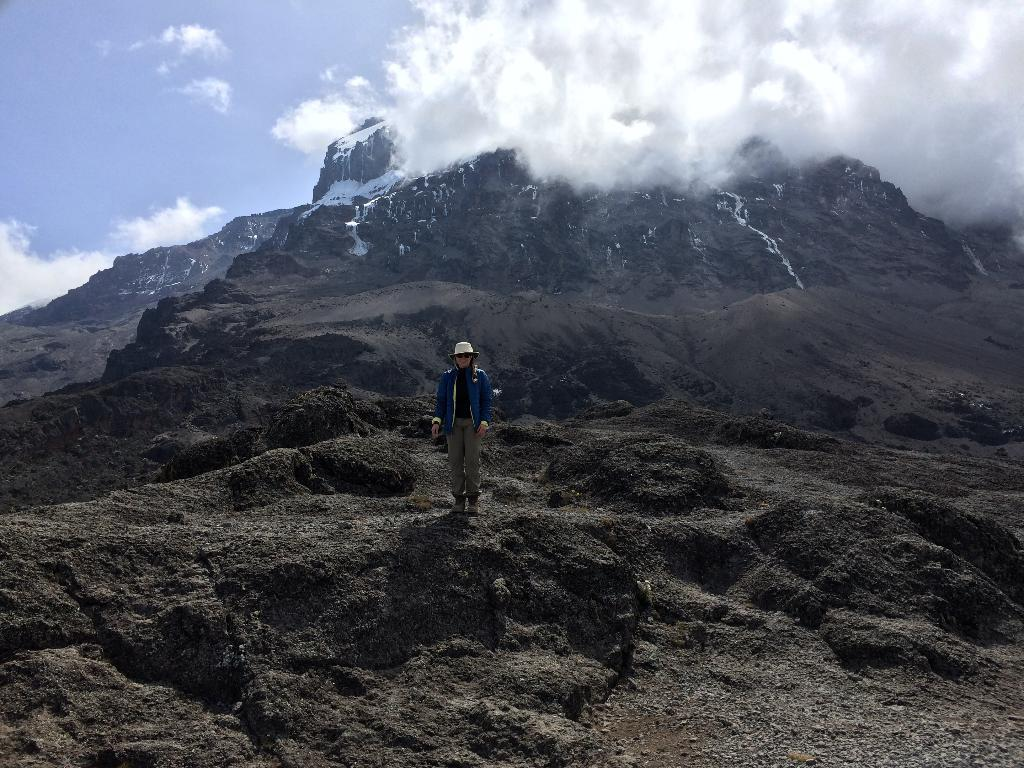What is the main subject of the image? There is a person standing in the image. What can be seen in the background of the image? There are snow mountains and the sky visible in the background of the image. What type of butter is being used to make the leather in the image? There is no butter or leather present in the image. 